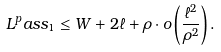Convert formula to latex. <formula><loc_0><loc_0><loc_500><loc_500>L ^ { p } a s s _ { 1 } \leq W + 2 \ell + \rho \cdot o \left ( \frac { \ell ^ { 2 } } { \rho ^ { 2 } } \right ) .</formula> 